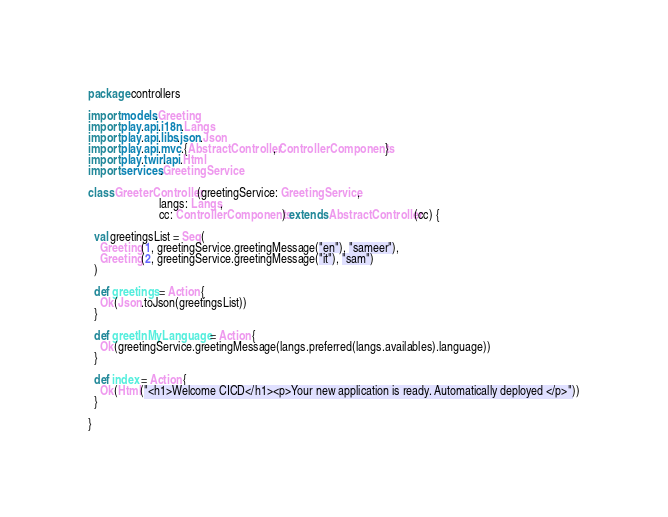Convert code to text. <code><loc_0><loc_0><loc_500><loc_500><_Scala_>package controllers

import models.Greeting
import play.api.i18n.Langs
import play.api.libs.json.Json
import play.api.mvc.{AbstractController, ControllerComponents}
import play.twirl.api.Html
import services.GreetingService

class GreeterController(greetingService: GreetingService,
                        langs: Langs,
                        cc: ControllerComponents) extends AbstractController(cc) {

  val greetingsList = Seq(
    Greeting(1, greetingService.greetingMessage("en"), "sameer"),
    Greeting(2, greetingService.greetingMessage("it"), "sam")
  )

  def greetings = Action {
    Ok(Json.toJson(greetingsList))
  }

  def greetInMyLanguage = Action {
    Ok(greetingService.greetingMessage(langs.preferred(langs.availables).language))
  }

  def index = Action {
    Ok(Html("<h1>Welcome CICD</h1><p>Your new application is ready. Automatically deployed </p>"))
  }

}
</code> 